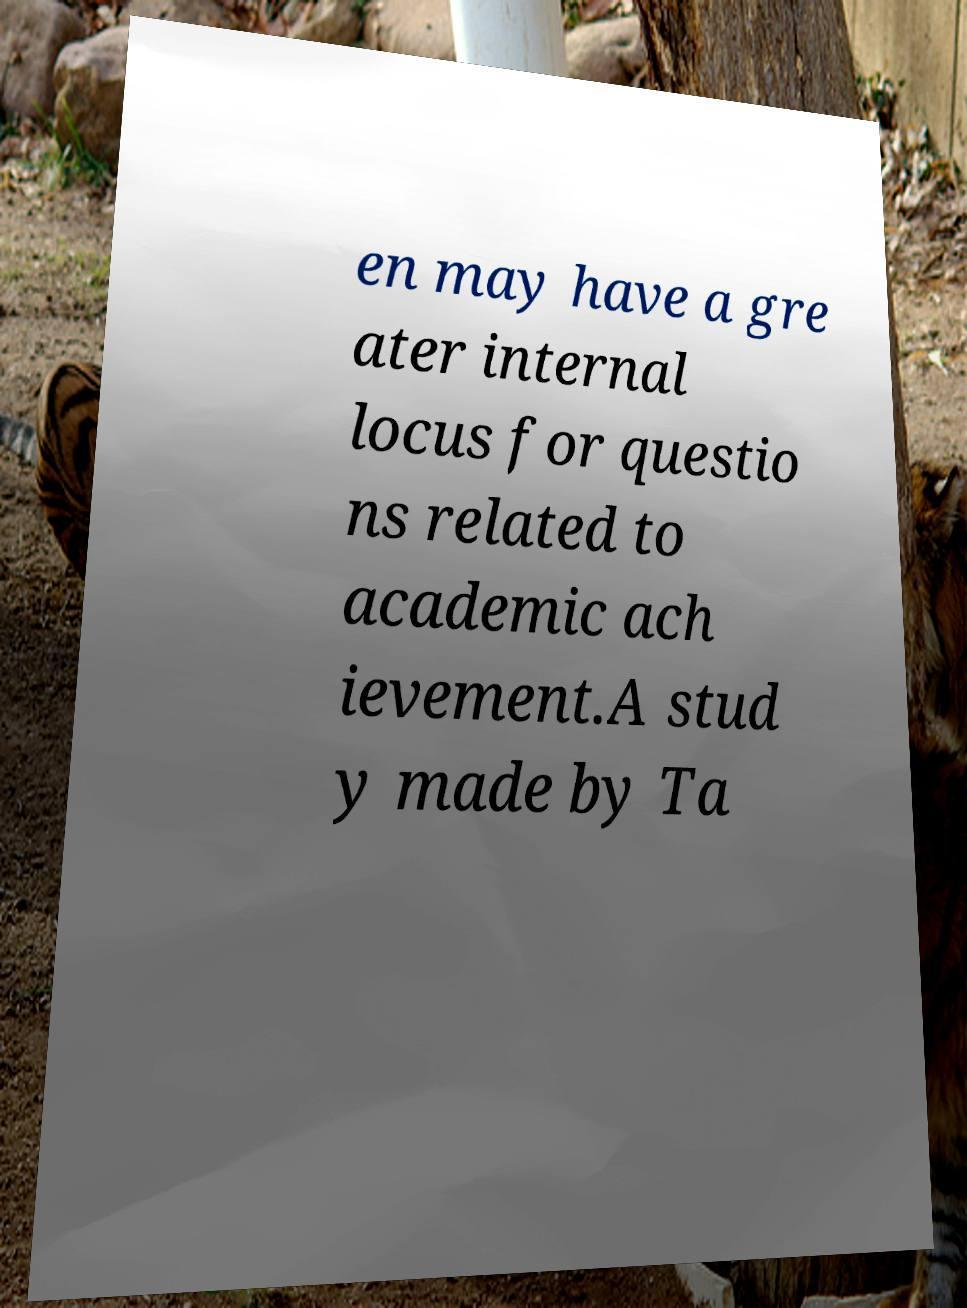Please read and relay the text visible in this image. What does it say? en may have a gre ater internal locus for questio ns related to academic ach ievement.A stud y made by Ta 